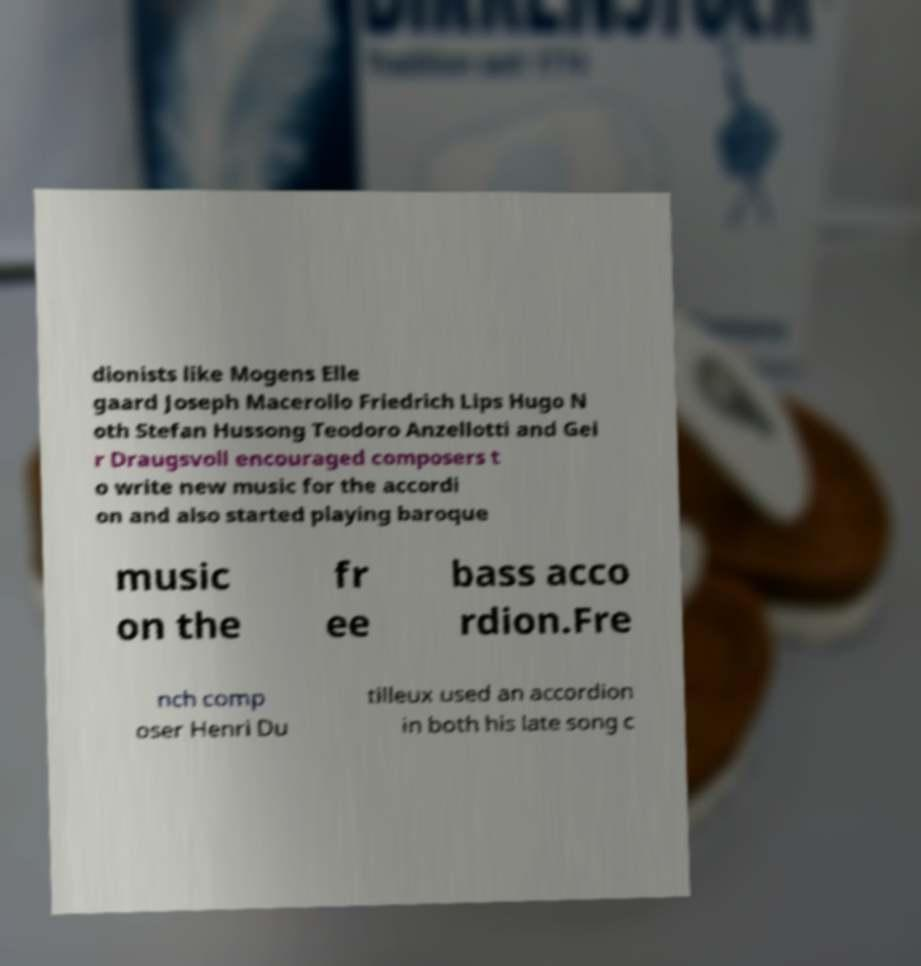Please read and relay the text visible in this image. What does it say? dionists like Mogens Elle gaard Joseph Macerollo Friedrich Lips Hugo N oth Stefan Hussong Teodoro Anzellotti and Gei r Draugsvoll encouraged composers t o write new music for the accordi on and also started playing baroque music on the fr ee bass acco rdion.Fre nch comp oser Henri Du tilleux used an accordion in both his late song c 